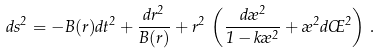Convert formula to latex. <formula><loc_0><loc_0><loc_500><loc_500>d s ^ { 2 } = - B ( r ) d t ^ { 2 } + \frac { d r ^ { 2 } } { B ( r ) } + r ^ { 2 } \, \left ( \frac { d \rho ^ { 2 } } { 1 - k \rho ^ { 2 } } + \rho ^ { 2 } d \phi ^ { 2 } \right ) \, .</formula> 